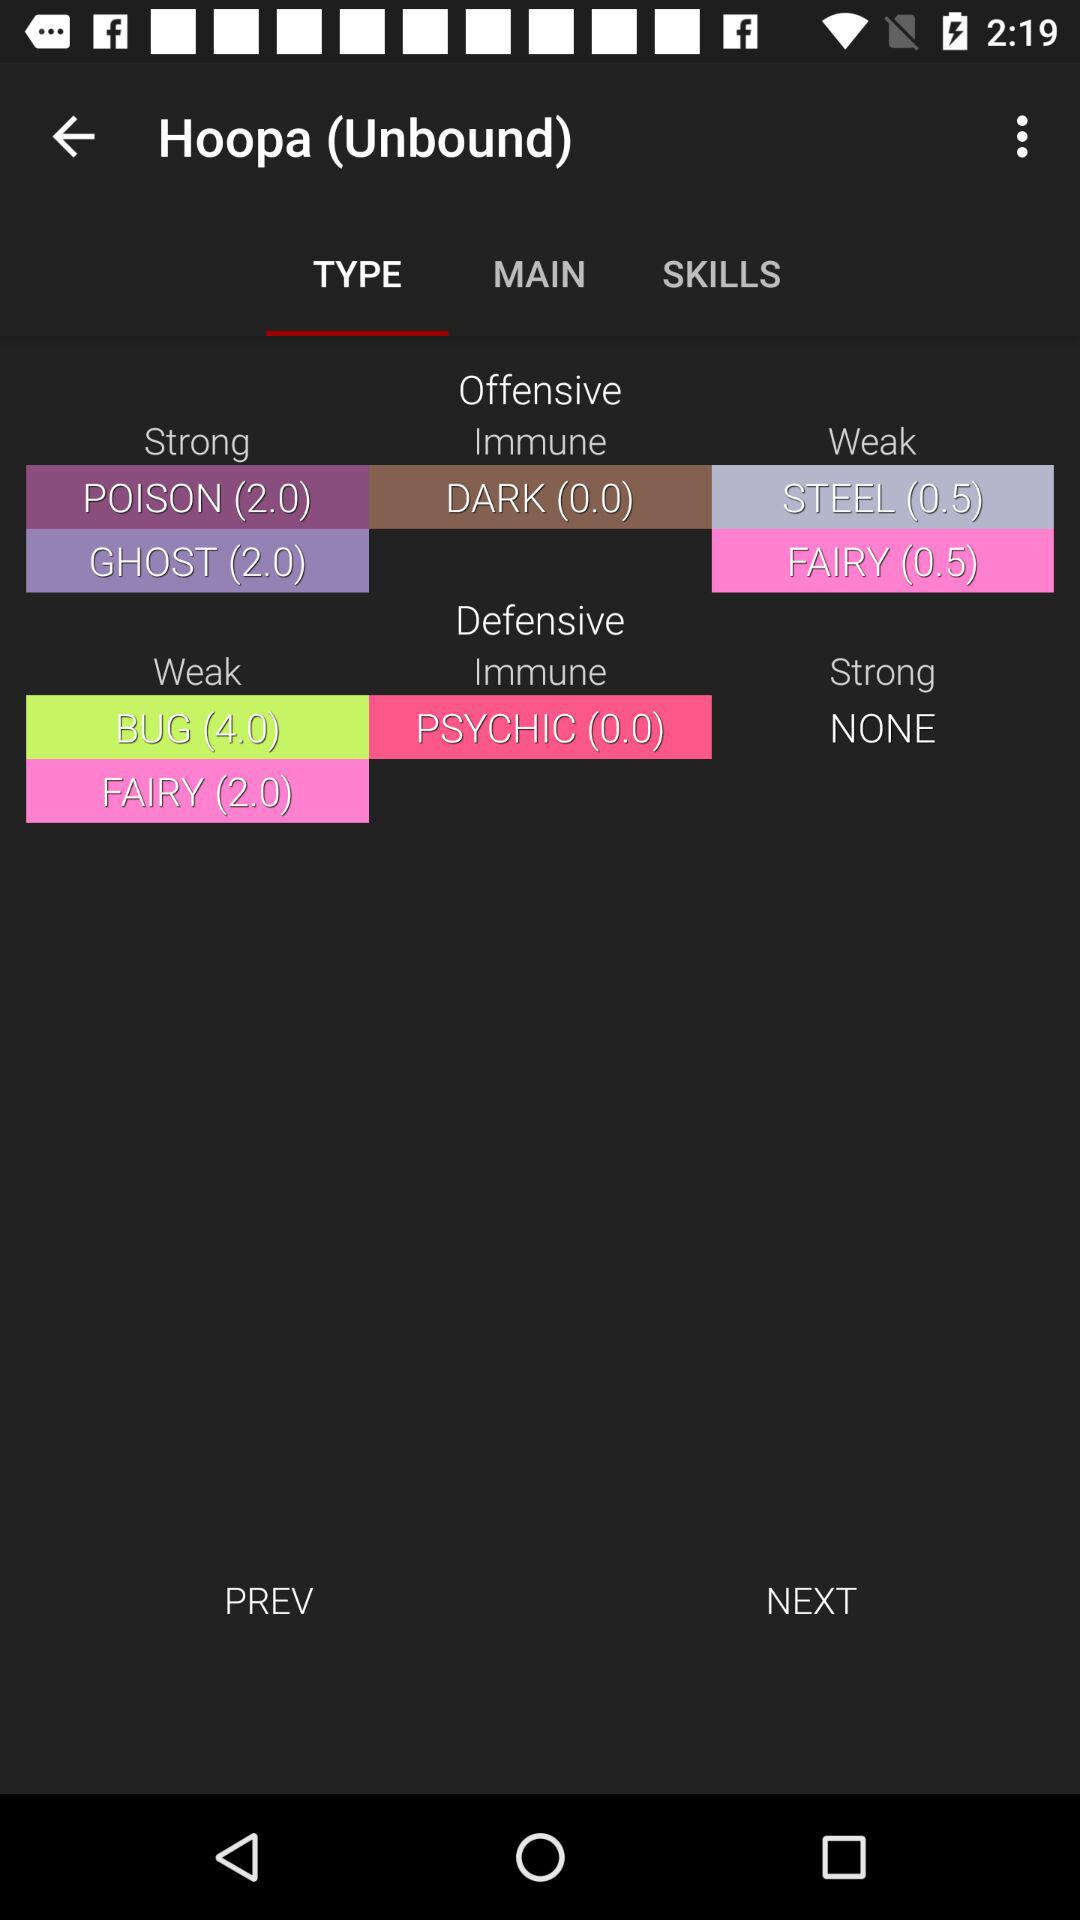What are the offensive points against "DARK" in "Immune"? The offensive points against "DARK" in "Immune" are 0. 